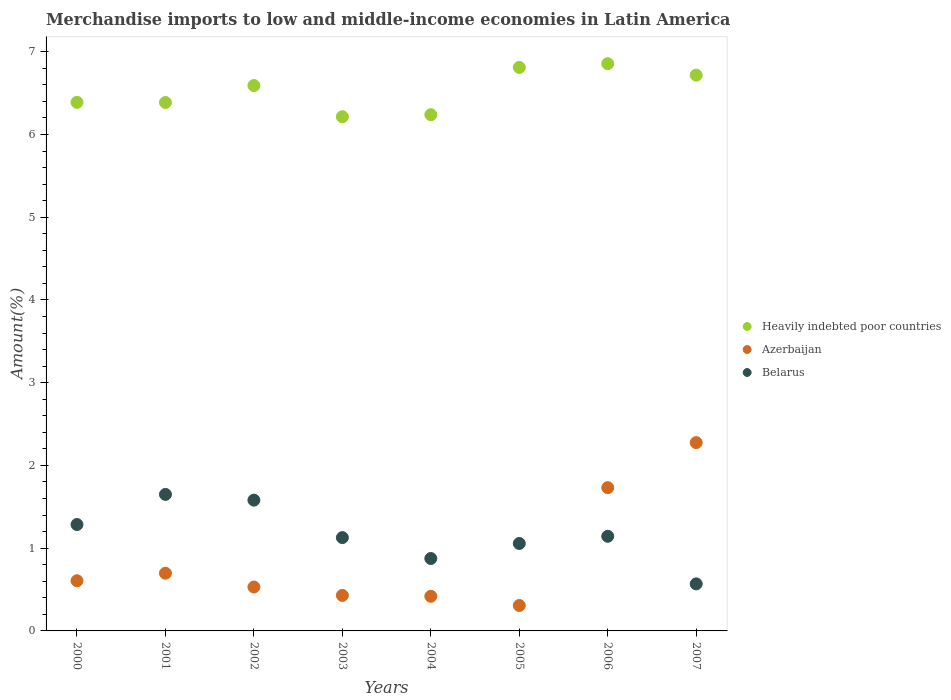Is the number of dotlines equal to the number of legend labels?
Keep it short and to the point. Yes. What is the percentage of amount earned from merchandise imports in Belarus in 2006?
Give a very brief answer. 1.14. Across all years, what is the maximum percentage of amount earned from merchandise imports in Belarus?
Keep it short and to the point. 1.65. Across all years, what is the minimum percentage of amount earned from merchandise imports in Belarus?
Offer a very short reply. 0.57. What is the total percentage of amount earned from merchandise imports in Azerbaijan in the graph?
Your response must be concise. 7. What is the difference between the percentage of amount earned from merchandise imports in Heavily indebted poor countries in 2000 and that in 2005?
Keep it short and to the point. -0.42. What is the difference between the percentage of amount earned from merchandise imports in Belarus in 2001 and the percentage of amount earned from merchandise imports in Azerbaijan in 2007?
Provide a short and direct response. -0.63. What is the average percentage of amount earned from merchandise imports in Azerbaijan per year?
Your answer should be compact. 0.87. In the year 2006, what is the difference between the percentage of amount earned from merchandise imports in Azerbaijan and percentage of amount earned from merchandise imports in Heavily indebted poor countries?
Make the answer very short. -5.12. What is the ratio of the percentage of amount earned from merchandise imports in Belarus in 2003 to that in 2006?
Give a very brief answer. 0.99. Is the difference between the percentage of amount earned from merchandise imports in Azerbaijan in 2001 and 2005 greater than the difference between the percentage of amount earned from merchandise imports in Heavily indebted poor countries in 2001 and 2005?
Offer a very short reply. Yes. What is the difference between the highest and the second highest percentage of amount earned from merchandise imports in Heavily indebted poor countries?
Provide a short and direct response. 0.05. What is the difference between the highest and the lowest percentage of amount earned from merchandise imports in Belarus?
Give a very brief answer. 1.08. Is the sum of the percentage of amount earned from merchandise imports in Azerbaijan in 2001 and 2002 greater than the maximum percentage of amount earned from merchandise imports in Heavily indebted poor countries across all years?
Provide a short and direct response. No. Is it the case that in every year, the sum of the percentage of amount earned from merchandise imports in Azerbaijan and percentage of amount earned from merchandise imports in Heavily indebted poor countries  is greater than the percentage of amount earned from merchandise imports in Belarus?
Keep it short and to the point. Yes. Is the percentage of amount earned from merchandise imports in Belarus strictly less than the percentage of amount earned from merchandise imports in Azerbaijan over the years?
Make the answer very short. No. How many dotlines are there?
Offer a terse response. 3. What is the difference between two consecutive major ticks on the Y-axis?
Offer a very short reply. 1. Does the graph contain grids?
Your answer should be very brief. No. How are the legend labels stacked?
Ensure brevity in your answer.  Vertical. What is the title of the graph?
Provide a short and direct response. Merchandise imports to low and middle-income economies in Latin America. Does "Azerbaijan" appear as one of the legend labels in the graph?
Make the answer very short. Yes. What is the label or title of the Y-axis?
Your response must be concise. Amount(%). What is the Amount(%) of Heavily indebted poor countries in 2000?
Keep it short and to the point. 6.39. What is the Amount(%) of Azerbaijan in 2000?
Ensure brevity in your answer.  0.61. What is the Amount(%) of Belarus in 2000?
Your response must be concise. 1.29. What is the Amount(%) in Heavily indebted poor countries in 2001?
Offer a very short reply. 6.39. What is the Amount(%) in Azerbaijan in 2001?
Provide a short and direct response. 0.7. What is the Amount(%) in Belarus in 2001?
Give a very brief answer. 1.65. What is the Amount(%) of Heavily indebted poor countries in 2002?
Give a very brief answer. 6.59. What is the Amount(%) of Azerbaijan in 2002?
Provide a succinct answer. 0.53. What is the Amount(%) in Belarus in 2002?
Offer a very short reply. 1.58. What is the Amount(%) in Heavily indebted poor countries in 2003?
Your answer should be compact. 6.21. What is the Amount(%) in Azerbaijan in 2003?
Give a very brief answer. 0.43. What is the Amount(%) in Belarus in 2003?
Your response must be concise. 1.13. What is the Amount(%) of Heavily indebted poor countries in 2004?
Make the answer very short. 6.24. What is the Amount(%) in Azerbaijan in 2004?
Give a very brief answer. 0.42. What is the Amount(%) of Belarus in 2004?
Your answer should be very brief. 0.88. What is the Amount(%) of Heavily indebted poor countries in 2005?
Keep it short and to the point. 6.81. What is the Amount(%) of Azerbaijan in 2005?
Make the answer very short. 0.31. What is the Amount(%) of Belarus in 2005?
Offer a very short reply. 1.06. What is the Amount(%) of Heavily indebted poor countries in 2006?
Offer a very short reply. 6.86. What is the Amount(%) of Azerbaijan in 2006?
Offer a terse response. 1.73. What is the Amount(%) of Belarus in 2006?
Make the answer very short. 1.14. What is the Amount(%) of Heavily indebted poor countries in 2007?
Offer a very short reply. 6.72. What is the Amount(%) in Azerbaijan in 2007?
Keep it short and to the point. 2.28. What is the Amount(%) of Belarus in 2007?
Your answer should be compact. 0.57. Across all years, what is the maximum Amount(%) of Heavily indebted poor countries?
Provide a short and direct response. 6.86. Across all years, what is the maximum Amount(%) of Azerbaijan?
Provide a short and direct response. 2.28. Across all years, what is the maximum Amount(%) in Belarus?
Offer a very short reply. 1.65. Across all years, what is the minimum Amount(%) of Heavily indebted poor countries?
Offer a terse response. 6.21. Across all years, what is the minimum Amount(%) of Azerbaijan?
Offer a terse response. 0.31. Across all years, what is the minimum Amount(%) of Belarus?
Your answer should be very brief. 0.57. What is the total Amount(%) of Heavily indebted poor countries in the graph?
Provide a succinct answer. 52.2. What is the total Amount(%) in Azerbaijan in the graph?
Keep it short and to the point. 7. What is the total Amount(%) in Belarus in the graph?
Make the answer very short. 9.29. What is the difference between the Amount(%) in Heavily indebted poor countries in 2000 and that in 2001?
Offer a terse response. 0. What is the difference between the Amount(%) in Azerbaijan in 2000 and that in 2001?
Ensure brevity in your answer.  -0.09. What is the difference between the Amount(%) in Belarus in 2000 and that in 2001?
Offer a terse response. -0.36. What is the difference between the Amount(%) in Heavily indebted poor countries in 2000 and that in 2002?
Offer a terse response. -0.2. What is the difference between the Amount(%) in Azerbaijan in 2000 and that in 2002?
Offer a very short reply. 0.08. What is the difference between the Amount(%) of Belarus in 2000 and that in 2002?
Give a very brief answer. -0.29. What is the difference between the Amount(%) in Heavily indebted poor countries in 2000 and that in 2003?
Your answer should be very brief. 0.17. What is the difference between the Amount(%) in Azerbaijan in 2000 and that in 2003?
Keep it short and to the point. 0.18. What is the difference between the Amount(%) of Belarus in 2000 and that in 2003?
Your answer should be compact. 0.16. What is the difference between the Amount(%) in Heavily indebted poor countries in 2000 and that in 2004?
Provide a succinct answer. 0.15. What is the difference between the Amount(%) of Azerbaijan in 2000 and that in 2004?
Provide a short and direct response. 0.19. What is the difference between the Amount(%) of Belarus in 2000 and that in 2004?
Offer a terse response. 0.41. What is the difference between the Amount(%) of Heavily indebted poor countries in 2000 and that in 2005?
Your answer should be very brief. -0.42. What is the difference between the Amount(%) of Azerbaijan in 2000 and that in 2005?
Your answer should be compact. 0.3. What is the difference between the Amount(%) in Belarus in 2000 and that in 2005?
Offer a terse response. 0.23. What is the difference between the Amount(%) of Heavily indebted poor countries in 2000 and that in 2006?
Ensure brevity in your answer.  -0.47. What is the difference between the Amount(%) in Azerbaijan in 2000 and that in 2006?
Your answer should be compact. -1.12. What is the difference between the Amount(%) of Belarus in 2000 and that in 2006?
Your response must be concise. 0.14. What is the difference between the Amount(%) in Heavily indebted poor countries in 2000 and that in 2007?
Provide a succinct answer. -0.33. What is the difference between the Amount(%) of Azerbaijan in 2000 and that in 2007?
Offer a very short reply. -1.67. What is the difference between the Amount(%) in Belarus in 2000 and that in 2007?
Provide a succinct answer. 0.72. What is the difference between the Amount(%) of Heavily indebted poor countries in 2001 and that in 2002?
Your answer should be very brief. -0.2. What is the difference between the Amount(%) in Azerbaijan in 2001 and that in 2002?
Provide a succinct answer. 0.17. What is the difference between the Amount(%) of Belarus in 2001 and that in 2002?
Your response must be concise. 0.07. What is the difference between the Amount(%) of Heavily indebted poor countries in 2001 and that in 2003?
Provide a short and direct response. 0.17. What is the difference between the Amount(%) of Azerbaijan in 2001 and that in 2003?
Provide a succinct answer. 0.27. What is the difference between the Amount(%) of Belarus in 2001 and that in 2003?
Offer a terse response. 0.52. What is the difference between the Amount(%) of Heavily indebted poor countries in 2001 and that in 2004?
Provide a succinct answer. 0.15. What is the difference between the Amount(%) in Azerbaijan in 2001 and that in 2004?
Ensure brevity in your answer.  0.28. What is the difference between the Amount(%) in Belarus in 2001 and that in 2004?
Your response must be concise. 0.77. What is the difference between the Amount(%) of Heavily indebted poor countries in 2001 and that in 2005?
Offer a very short reply. -0.42. What is the difference between the Amount(%) in Azerbaijan in 2001 and that in 2005?
Ensure brevity in your answer.  0.39. What is the difference between the Amount(%) in Belarus in 2001 and that in 2005?
Give a very brief answer. 0.59. What is the difference between the Amount(%) of Heavily indebted poor countries in 2001 and that in 2006?
Your answer should be very brief. -0.47. What is the difference between the Amount(%) of Azerbaijan in 2001 and that in 2006?
Provide a succinct answer. -1.03. What is the difference between the Amount(%) in Belarus in 2001 and that in 2006?
Your answer should be compact. 0.51. What is the difference between the Amount(%) of Heavily indebted poor countries in 2001 and that in 2007?
Provide a short and direct response. -0.33. What is the difference between the Amount(%) in Azerbaijan in 2001 and that in 2007?
Offer a very short reply. -1.58. What is the difference between the Amount(%) of Belarus in 2001 and that in 2007?
Offer a terse response. 1.08. What is the difference between the Amount(%) in Heavily indebted poor countries in 2002 and that in 2003?
Your response must be concise. 0.38. What is the difference between the Amount(%) in Azerbaijan in 2002 and that in 2003?
Offer a very short reply. 0.1. What is the difference between the Amount(%) in Belarus in 2002 and that in 2003?
Your answer should be very brief. 0.45. What is the difference between the Amount(%) of Heavily indebted poor countries in 2002 and that in 2004?
Your answer should be compact. 0.35. What is the difference between the Amount(%) of Azerbaijan in 2002 and that in 2004?
Make the answer very short. 0.11. What is the difference between the Amount(%) of Belarus in 2002 and that in 2004?
Keep it short and to the point. 0.71. What is the difference between the Amount(%) of Heavily indebted poor countries in 2002 and that in 2005?
Keep it short and to the point. -0.22. What is the difference between the Amount(%) of Azerbaijan in 2002 and that in 2005?
Make the answer very short. 0.22. What is the difference between the Amount(%) of Belarus in 2002 and that in 2005?
Your response must be concise. 0.52. What is the difference between the Amount(%) of Heavily indebted poor countries in 2002 and that in 2006?
Provide a succinct answer. -0.26. What is the difference between the Amount(%) in Azerbaijan in 2002 and that in 2006?
Your answer should be compact. -1.2. What is the difference between the Amount(%) of Belarus in 2002 and that in 2006?
Your answer should be compact. 0.44. What is the difference between the Amount(%) of Heavily indebted poor countries in 2002 and that in 2007?
Give a very brief answer. -0.13. What is the difference between the Amount(%) of Azerbaijan in 2002 and that in 2007?
Provide a short and direct response. -1.75. What is the difference between the Amount(%) in Heavily indebted poor countries in 2003 and that in 2004?
Make the answer very short. -0.02. What is the difference between the Amount(%) of Azerbaijan in 2003 and that in 2004?
Provide a short and direct response. 0.01. What is the difference between the Amount(%) in Belarus in 2003 and that in 2004?
Your response must be concise. 0.25. What is the difference between the Amount(%) of Heavily indebted poor countries in 2003 and that in 2005?
Ensure brevity in your answer.  -0.6. What is the difference between the Amount(%) in Azerbaijan in 2003 and that in 2005?
Your answer should be very brief. 0.12. What is the difference between the Amount(%) of Belarus in 2003 and that in 2005?
Offer a very short reply. 0.07. What is the difference between the Amount(%) of Heavily indebted poor countries in 2003 and that in 2006?
Your response must be concise. -0.64. What is the difference between the Amount(%) in Azerbaijan in 2003 and that in 2006?
Give a very brief answer. -1.3. What is the difference between the Amount(%) in Belarus in 2003 and that in 2006?
Give a very brief answer. -0.02. What is the difference between the Amount(%) in Heavily indebted poor countries in 2003 and that in 2007?
Provide a short and direct response. -0.5. What is the difference between the Amount(%) of Azerbaijan in 2003 and that in 2007?
Provide a short and direct response. -1.85. What is the difference between the Amount(%) of Belarus in 2003 and that in 2007?
Offer a very short reply. 0.56. What is the difference between the Amount(%) of Heavily indebted poor countries in 2004 and that in 2005?
Provide a succinct answer. -0.57. What is the difference between the Amount(%) of Azerbaijan in 2004 and that in 2005?
Provide a short and direct response. 0.11. What is the difference between the Amount(%) of Belarus in 2004 and that in 2005?
Keep it short and to the point. -0.18. What is the difference between the Amount(%) in Heavily indebted poor countries in 2004 and that in 2006?
Give a very brief answer. -0.62. What is the difference between the Amount(%) in Azerbaijan in 2004 and that in 2006?
Your answer should be compact. -1.31. What is the difference between the Amount(%) of Belarus in 2004 and that in 2006?
Provide a short and direct response. -0.27. What is the difference between the Amount(%) of Heavily indebted poor countries in 2004 and that in 2007?
Give a very brief answer. -0.48. What is the difference between the Amount(%) in Azerbaijan in 2004 and that in 2007?
Your answer should be compact. -1.86. What is the difference between the Amount(%) of Belarus in 2004 and that in 2007?
Make the answer very short. 0.31. What is the difference between the Amount(%) of Heavily indebted poor countries in 2005 and that in 2006?
Provide a succinct answer. -0.05. What is the difference between the Amount(%) of Azerbaijan in 2005 and that in 2006?
Your response must be concise. -1.42. What is the difference between the Amount(%) of Belarus in 2005 and that in 2006?
Keep it short and to the point. -0.09. What is the difference between the Amount(%) of Heavily indebted poor countries in 2005 and that in 2007?
Make the answer very short. 0.09. What is the difference between the Amount(%) in Azerbaijan in 2005 and that in 2007?
Provide a succinct answer. -1.97. What is the difference between the Amount(%) in Belarus in 2005 and that in 2007?
Your response must be concise. 0.49. What is the difference between the Amount(%) of Heavily indebted poor countries in 2006 and that in 2007?
Your response must be concise. 0.14. What is the difference between the Amount(%) in Azerbaijan in 2006 and that in 2007?
Offer a terse response. -0.54. What is the difference between the Amount(%) in Belarus in 2006 and that in 2007?
Keep it short and to the point. 0.58. What is the difference between the Amount(%) of Heavily indebted poor countries in 2000 and the Amount(%) of Azerbaijan in 2001?
Ensure brevity in your answer.  5.69. What is the difference between the Amount(%) of Heavily indebted poor countries in 2000 and the Amount(%) of Belarus in 2001?
Ensure brevity in your answer.  4.74. What is the difference between the Amount(%) of Azerbaijan in 2000 and the Amount(%) of Belarus in 2001?
Your response must be concise. -1.04. What is the difference between the Amount(%) of Heavily indebted poor countries in 2000 and the Amount(%) of Azerbaijan in 2002?
Make the answer very short. 5.86. What is the difference between the Amount(%) of Heavily indebted poor countries in 2000 and the Amount(%) of Belarus in 2002?
Ensure brevity in your answer.  4.81. What is the difference between the Amount(%) in Azerbaijan in 2000 and the Amount(%) in Belarus in 2002?
Provide a short and direct response. -0.97. What is the difference between the Amount(%) of Heavily indebted poor countries in 2000 and the Amount(%) of Azerbaijan in 2003?
Keep it short and to the point. 5.96. What is the difference between the Amount(%) in Heavily indebted poor countries in 2000 and the Amount(%) in Belarus in 2003?
Make the answer very short. 5.26. What is the difference between the Amount(%) of Azerbaijan in 2000 and the Amount(%) of Belarus in 2003?
Offer a very short reply. -0.52. What is the difference between the Amount(%) of Heavily indebted poor countries in 2000 and the Amount(%) of Azerbaijan in 2004?
Offer a very short reply. 5.97. What is the difference between the Amount(%) of Heavily indebted poor countries in 2000 and the Amount(%) of Belarus in 2004?
Your answer should be very brief. 5.51. What is the difference between the Amount(%) in Azerbaijan in 2000 and the Amount(%) in Belarus in 2004?
Give a very brief answer. -0.27. What is the difference between the Amount(%) of Heavily indebted poor countries in 2000 and the Amount(%) of Azerbaijan in 2005?
Your response must be concise. 6.08. What is the difference between the Amount(%) in Heavily indebted poor countries in 2000 and the Amount(%) in Belarus in 2005?
Keep it short and to the point. 5.33. What is the difference between the Amount(%) in Azerbaijan in 2000 and the Amount(%) in Belarus in 2005?
Offer a terse response. -0.45. What is the difference between the Amount(%) of Heavily indebted poor countries in 2000 and the Amount(%) of Azerbaijan in 2006?
Your answer should be very brief. 4.66. What is the difference between the Amount(%) in Heavily indebted poor countries in 2000 and the Amount(%) in Belarus in 2006?
Offer a terse response. 5.24. What is the difference between the Amount(%) in Azerbaijan in 2000 and the Amount(%) in Belarus in 2006?
Your answer should be very brief. -0.54. What is the difference between the Amount(%) of Heavily indebted poor countries in 2000 and the Amount(%) of Azerbaijan in 2007?
Give a very brief answer. 4.11. What is the difference between the Amount(%) of Heavily indebted poor countries in 2000 and the Amount(%) of Belarus in 2007?
Provide a short and direct response. 5.82. What is the difference between the Amount(%) of Azerbaijan in 2000 and the Amount(%) of Belarus in 2007?
Make the answer very short. 0.04. What is the difference between the Amount(%) of Heavily indebted poor countries in 2001 and the Amount(%) of Azerbaijan in 2002?
Provide a succinct answer. 5.86. What is the difference between the Amount(%) of Heavily indebted poor countries in 2001 and the Amount(%) of Belarus in 2002?
Give a very brief answer. 4.81. What is the difference between the Amount(%) of Azerbaijan in 2001 and the Amount(%) of Belarus in 2002?
Provide a short and direct response. -0.88. What is the difference between the Amount(%) of Heavily indebted poor countries in 2001 and the Amount(%) of Azerbaijan in 2003?
Ensure brevity in your answer.  5.96. What is the difference between the Amount(%) of Heavily indebted poor countries in 2001 and the Amount(%) of Belarus in 2003?
Your response must be concise. 5.26. What is the difference between the Amount(%) of Azerbaijan in 2001 and the Amount(%) of Belarus in 2003?
Your answer should be compact. -0.43. What is the difference between the Amount(%) in Heavily indebted poor countries in 2001 and the Amount(%) in Azerbaijan in 2004?
Your response must be concise. 5.97. What is the difference between the Amount(%) of Heavily indebted poor countries in 2001 and the Amount(%) of Belarus in 2004?
Make the answer very short. 5.51. What is the difference between the Amount(%) in Azerbaijan in 2001 and the Amount(%) in Belarus in 2004?
Keep it short and to the point. -0.18. What is the difference between the Amount(%) of Heavily indebted poor countries in 2001 and the Amount(%) of Azerbaijan in 2005?
Keep it short and to the point. 6.08. What is the difference between the Amount(%) of Heavily indebted poor countries in 2001 and the Amount(%) of Belarus in 2005?
Your response must be concise. 5.33. What is the difference between the Amount(%) in Azerbaijan in 2001 and the Amount(%) in Belarus in 2005?
Your response must be concise. -0.36. What is the difference between the Amount(%) in Heavily indebted poor countries in 2001 and the Amount(%) in Azerbaijan in 2006?
Offer a very short reply. 4.66. What is the difference between the Amount(%) of Heavily indebted poor countries in 2001 and the Amount(%) of Belarus in 2006?
Offer a very short reply. 5.24. What is the difference between the Amount(%) in Azerbaijan in 2001 and the Amount(%) in Belarus in 2006?
Keep it short and to the point. -0.45. What is the difference between the Amount(%) in Heavily indebted poor countries in 2001 and the Amount(%) in Azerbaijan in 2007?
Offer a very short reply. 4.11. What is the difference between the Amount(%) of Heavily indebted poor countries in 2001 and the Amount(%) of Belarus in 2007?
Provide a succinct answer. 5.82. What is the difference between the Amount(%) in Azerbaijan in 2001 and the Amount(%) in Belarus in 2007?
Ensure brevity in your answer.  0.13. What is the difference between the Amount(%) in Heavily indebted poor countries in 2002 and the Amount(%) in Azerbaijan in 2003?
Provide a short and direct response. 6.16. What is the difference between the Amount(%) in Heavily indebted poor countries in 2002 and the Amount(%) in Belarus in 2003?
Your answer should be very brief. 5.46. What is the difference between the Amount(%) of Azerbaijan in 2002 and the Amount(%) of Belarus in 2003?
Offer a terse response. -0.6. What is the difference between the Amount(%) in Heavily indebted poor countries in 2002 and the Amount(%) in Azerbaijan in 2004?
Your answer should be compact. 6.17. What is the difference between the Amount(%) in Heavily indebted poor countries in 2002 and the Amount(%) in Belarus in 2004?
Provide a short and direct response. 5.72. What is the difference between the Amount(%) in Azerbaijan in 2002 and the Amount(%) in Belarus in 2004?
Keep it short and to the point. -0.34. What is the difference between the Amount(%) of Heavily indebted poor countries in 2002 and the Amount(%) of Azerbaijan in 2005?
Your response must be concise. 6.28. What is the difference between the Amount(%) of Heavily indebted poor countries in 2002 and the Amount(%) of Belarus in 2005?
Keep it short and to the point. 5.53. What is the difference between the Amount(%) in Azerbaijan in 2002 and the Amount(%) in Belarus in 2005?
Offer a terse response. -0.53. What is the difference between the Amount(%) of Heavily indebted poor countries in 2002 and the Amount(%) of Azerbaijan in 2006?
Keep it short and to the point. 4.86. What is the difference between the Amount(%) of Heavily indebted poor countries in 2002 and the Amount(%) of Belarus in 2006?
Ensure brevity in your answer.  5.45. What is the difference between the Amount(%) of Azerbaijan in 2002 and the Amount(%) of Belarus in 2006?
Offer a very short reply. -0.61. What is the difference between the Amount(%) of Heavily indebted poor countries in 2002 and the Amount(%) of Azerbaijan in 2007?
Your answer should be very brief. 4.32. What is the difference between the Amount(%) in Heavily indebted poor countries in 2002 and the Amount(%) in Belarus in 2007?
Provide a succinct answer. 6.02. What is the difference between the Amount(%) in Azerbaijan in 2002 and the Amount(%) in Belarus in 2007?
Your answer should be very brief. -0.04. What is the difference between the Amount(%) in Heavily indebted poor countries in 2003 and the Amount(%) in Azerbaijan in 2004?
Give a very brief answer. 5.8. What is the difference between the Amount(%) in Heavily indebted poor countries in 2003 and the Amount(%) in Belarus in 2004?
Give a very brief answer. 5.34. What is the difference between the Amount(%) of Azerbaijan in 2003 and the Amount(%) of Belarus in 2004?
Ensure brevity in your answer.  -0.45. What is the difference between the Amount(%) in Heavily indebted poor countries in 2003 and the Amount(%) in Azerbaijan in 2005?
Provide a short and direct response. 5.91. What is the difference between the Amount(%) in Heavily indebted poor countries in 2003 and the Amount(%) in Belarus in 2005?
Ensure brevity in your answer.  5.16. What is the difference between the Amount(%) of Azerbaijan in 2003 and the Amount(%) of Belarus in 2005?
Ensure brevity in your answer.  -0.63. What is the difference between the Amount(%) in Heavily indebted poor countries in 2003 and the Amount(%) in Azerbaijan in 2006?
Your answer should be very brief. 4.48. What is the difference between the Amount(%) of Heavily indebted poor countries in 2003 and the Amount(%) of Belarus in 2006?
Make the answer very short. 5.07. What is the difference between the Amount(%) in Azerbaijan in 2003 and the Amount(%) in Belarus in 2006?
Give a very brief answer. -0.71. What is the difference between the Amount(%) of Heavily indebted poor countries in 2003 and the Amount(%) of Azerbaijan in 2007?
Give a very brief answer. 3.94. What is the difference between the Amount(%) of Heavily indebted poor countries in 2003 and the Amount(%) of Belarus in 2007?
Provide a short and direct response. 5.65. What is the difference between the Amount(%) in Azerbaijan in 2003 and the Amount(%) in Belarus in 2007?
Make the answer very short. -0.14. What is the difference between the Amount(%) of Heavily indebted poor countries in 2004 and the Amount(%) of Azerbaijan in 2005?
Offer a terse response. 5.93. What is the difference between the Amount(%) of Heavily indebted poor countries in 2004 and the Amount(%) of Belarus in 2005?
Your answer should be very brief. 5.18. What is the difference between the Amount(%) of Azerbaijan in 2004 and the Amount(%) of Belarus in 2005?
Offer a very short reply. -0.64. What is the difference between the Amount(%) of Heavily indebted poor countries in 2004 and the Amount(%) of Azerbaijan in 2006?
Make the answer very short. 4.51. What is the difference between the Amount(%) of Heavily indebted poor countries in 2004 and the Amount(%) of Belarus in 2006?
Provide a short and direct response. 5.1. What is the difference between the Amount(%) of Azerbaijan in 2004 and the Amount(%) of Belarus in 2006?
Make the answer very short. -0.73. What is the difference between the Amount(%) of Heavily indebted poor countries in 2004 and the Amount(%) of Azerbaijan in 2007?
Make the answer very short. 3.96. What is the difference between the Amount(%) in Heavily indebted poor countries in 2004 and the Amount(%) in Belarus in 2007?
Offer a very short reply. 5.67. What is the difference between the Amount(%) in Azerbaijan in 2004 and the Amount(%) in Belarus in 2007?
Give a very brief answer. -0.15. What is the difference between the Amount(%) of Heavily indebted poor countries in 2005 and the Amount(%) of Azerbaijan in 2006?
Provide a short and direct response. 5.08. What is the difference between the Amount(%) of Heavily indebted poor countries in 2005 and the Amount(%) of Belarus in 2006?
Ensure brevity in your answer.  5.67. What is the difference between the Amount(%) in Azerbaijan in 2005 and the Amount(%) in Belarus in 2006?
Your answer should be very brief. -0.84. What is the difference between the Amount(%) of Heavily indebted poor countries in 2005 and the Amount(%) of Azerbaijan in 2007?
Your answer should be very brief. 4.53. What is the difference between the Amount(%) in Heavily indebted poor countries in 2005 and the Amount(%) in Belarus in 2007?
Offer a terse response. 6.24. What is the difference between the Amount(%) in Azerbaijan in 2005 and the Amount(%) in Belarus in 2007?
Offer a terse response. -0.26. What is the difference between the Amount(%) of Heavily indebted poor countries in 2006 and the Amount(%) of Azerbaijan in 2007?
Your answer should be very brief. 4.58. What is the difference between the Amount(%) of Heavily indebted poor countries in 2006 and the Amount(%) of Belarus in 2007?
Your response must be concise. 6.29. What is the difference between the Amount(%) in Azerbaijan in 2006 and the Amount(%) in Belarus in 2007?
Offer a terse response. 1.16. What is the average Amount(%) in Heavily indebted poor countries per year?
Offer a terse response. 6.53. What is the average Amount(%) in Azerbaijan per year?
Make the answer very short. 0.87. What is the average Amount(%) in Belarus per year?
Make the answer very short. 1.16. In the year 2000, what is the difference between the Amount(%) in Heavily indebted poor countries and Amount(%) in Azerbaijan?
Provide a short and direct response. 5.78. In the year 2000, what is the difference between the Amount(%) in Heavily indebted poor countries and Amount(%) in Belarus?
Your answer should be very brief. 5.1. In the year 2000, what is the difference between the Amount(%) of Azerbaijan and Amount(%) of Belarus?
Ensure brevity in your answer.  -0.68. In the year 2001, what is the difference between the Amount(%) in Heavily indebted poor countries and Amount(%) in Azerbaijan?
Offer a very short reply. 5.69. In the year 2001, what is the difference between the Amount(%) in Heavily indebted poor countries and Amount(%) in Belarus?
Provide a short and direct response. 4.74. In the year 2001, what is the difference between the Amount(%) of Azerbaijan and Amount(%) of Belarus?
Provide a succinct answer. -0.95. In the year 2002, what is the difference between the Amount(%) of Heavily indebted poor countries and Amount(%) of Azerbaijan?
Your answer should be very brief. 6.06. In the year 2002, what is the difference between the Amount(%) of Heavily indebted poor countries and Amount(%) of Belarus?
Offer a terse response. 5.01. In the year 2002, what is the difference between the Amount(%) of Azerbaijan and Amount(%) of Belarus?
Your answer should be very brief. -1.05. In the year 2003, what is the difference between the Amount(%) in Heavily indebted poor countries and Amount(%) in Azerbaijan?
Your answer should be very brief. 5.79. In the year 2003, what is the difference between the Amount(%) in Heavily indebted poor countries and Amount(%) in Belarus?
Give a very brief answer. 5.09. In the year 2003, what is the difference between the Amount(%) in Azerbaijan and Amount(%) in Belarus?
Provide a succinct answer. -0.7. In the year 2004, what is the difference between the Amount(%) in Heavily indebted poor countries and Amount(%) in Azerbaijan?
Your answer should be very brief. 5.82. In the year 2004, what is the difference between the Amount(%) of Heavily indebted poor countries and Amount(%) of Belarus?
Offer a terse response. 5.36. In the year 2004, what is the difference between the Amount(%) of Azerbaijan and Amount(%) of Belarus?
Offer a terse response. -0.46. In the year 2005, what is the difference between the Amount(%) in Heavily indebted poor countries and Amount(%) in Azerbaijan?
Your answer should be compact. 6.5. In the year 2005, what is the difference between the Amount(%) of Heavily indebted poor countries and Amount(%) of Belarus?
Your response must be concise. 5.75. In the year 2005, what is the difference between the Amount(%) in Azerbaijan and Amount(%) in Belarus?
Offer a very short reply. -0.75. In the year 2006, what is the difference between the Amount(%) of Heavily indebted poor countries and Amount(%) of Azerbaijan?
Keep it short and to the point. 5.12. In the year 2006, what is the difference between the Amount(%) in Heavily indebted poor countries and Amount(%) in Belarus?
Give a very brief answer. 5.71. In the year 2006, what is the difference between the Amount(%) in Azerbaijan and Amount(%) in Belarus?
Offer a very short reply. 0.59. In the year 2007, what is the difference between the Amount(%) in Heavily indebted poor countries and Amount(%) in Azerbaijan?
Keep it short and to the point. 4.44. In the year 2007, what is the difference between the Amount(%) in Heavily indebted poor countries and Amount(%) in Belarus?
Offer a terse response. 6.15. In the year 2007, what is the difference between the Amount(%) of Azerbaijan and Amount(%) of Belarus?
Provide a short and direct response. 1.71. What is the ratio of the Amount(%) of Heavily indebted poor countries in 2000 to that in 2001?
Ensure brevity in your answer.  1. What is the ratio of the Amount(%) in Azerbaijan in 2000 to that in 2001?
Provide a short and direct response. 0.87. What is the ratio of the Amount(%) in Belarus in 2000 to that in 2001?
Provide a short and direct response. 0.78. What is the ratio of the Amount(%) of Heavily indebted poor countries in 2000 to that in 2002?
Give a very brief answer. 0.97. What is the ratio of the Amount(%) of Azerbaijan in 2000 to that in 2002?
Offer a very short reply. 1.14. What is the ratio of the Amount(%) of Belarus in 2000 to that in 2002?
Your response must be concise. 0.81. What is the ratio of the Amount(%) in Heavily indebted poor countries in 2000 to that in 2003?
Your response must be concise. 1.03. What is the ratio of the Amount(%) of Azerbaijan in 2000 to that in 2003?
Provide a succinct answer. 1.41. What is the ratio of the Amount(%) of Belarus in 2000 to that in 2003?
Make the answer very short. 1.14. What is the ratio of the Amount(%) in Heavily indebted poor countries in 2000 to that in 2004?
Your response must be concise. 1.02. What is the ratio of the Amount(%) in Azerbaijan in 2000 to that in 2004?
Offer a terse response. 1.45. What is the ratio of the Amount(%) in Belarus in 2000 to that in 2004?
Ensure brevity in your answer.  1.47. What is the ratio of the Amount(%) in Heavily indebted poor countries in 2000 to that in 2005?
Make the answer very short. 0.94. What is the ratio of the Amount(%) in Azerbaijan in 2000 to that in 2005?
Ensure brevity in your answer.  1.97. What is the ratio of the Amount(%) in Belarus in 2000 to that in 2005?
Your response must be concise. 1.22. What is the ratio of the Amount(%) of Heavily indebted poor countries in 2000 to that in 2006?
Make the answer very short. 0.93. What is the ratio of the Amount(%) in Azerbaijan in 2000 to that in 2006?
Give a very brief answer. 0.35. What is the ratio of the Amount(%) in Belarus in 2000 to that in 2006?
Provide a succinct answer. 1.12. What is the ratio of the Amount(%) in Heavily indebted poor countries in 2000 to that in 2007?
Offer a very short reply. 0.95. What is the ratio of the Amount(%) of Azerbaijan in 2000 to that in 2007?
Offer a terse response. 0.27. What is the ratio of the Amount(%) of Belarus in 2000 to that in 2007?
Keep it short and to the point. 2.26. What is the ratio of the Amount(%) in Heavily indebted poor countries in 2001 to that in 2002?
Provide a short and direct response. 0.97. What is the ratio of the Amount(%) in Azerbaijan in 2001 to that in 2002?
Provide a succinct answer. 1.31. What is the ratio of the Amount(%) in Belarus in 2001 to that in 2002?
Make the answer very short. 1.04. What is the ratio of the Amount(%) in Heavily indebted poor countries in 2001 to that in 2003?
Provide a succinct answer. 1.03. What is the ratio of the Amount(%) of Azerbaijan in 2001 to that in 2003?
Keep it short and to the point. 1.62. What is the ratio of the Amount(%) of Belarus in 2001 to that in 2003?
Offer a terse response. 1.46. What is the ratio of the Amount(%) of Heavily indebted poor countries in 2001 to that in 2004?
Make the answer very short. 1.02. What is the ratio of the Amount(%) in Azerbaijan in 2001 to that in 2004?
Offer a terse response. 1.67. What is the ratio of the Amount(%) of Belarus in 2001 to that in 2004?
Your response must be concise. 1.89. What is the ratio of the Amount(%) of Heavily indebted poor countries in 2001 to that in 2005?
Offer a terse response. 0.94. What is the ratio of the Amount(%) of Azerbaijan in 2001 to that in 2005?
Give a very brief answer. 2.27. What is the ratio of the Amount(%) of Belarus in 2001 to that in 2005?
Provide a succinct answer. 1.56. What is the ratio of the Amount(%) of Heavily indebted poor countries in 2001 to that in 2006?
Your response must be concise. 0.93. What is the ratio of the Amount(%) of Azerbaijan in 2001 to that in 2006?
Ensure brevity in your answer.  0.4. What is the ratio of the Amount(%) in Belarus in 2001 to that in 2006?
Your answer should be compact. 1.44. What is the ratio of the Amount(%) of Heavily indebted poor countries in 2001 to that in 2007?
Your answer should be very brief. 0.95. What is the ratio of the Amount(%) in Azerbaijan in 2001 to that in 2007?
Offer a terse response. 0.31. What is the ratio of the Amount(%) in Belarus in 2001 to that in 2007?
Provide a succinct answer. 2.9. What is the ratio of the Amount(%) of Heavily indebted poor countries in 2002 to that in 2003?
Keep it short and to the point. 1.06. What is the ratio of the Amount(%) in Azerbaijan in 2002 to that in 2003?
Provide a short and direct response. 1.24. What is the ratio of the Amount(%) of Belarus in 2002 to that in 2003?
Your response must be concise. 1.4. What is the ratio of the Amount(%) of Heavily indebted poor countries in 2002 to that in 2004?
Ensure brevity in your answer.  1.06. What is the ratio of the Amount(%) of Azerbaijan in 2002 to that in 2004?
Provide a short and direct response. 1.27. What is the ratio of the Amount(%) of Belarus in 2002 to that in 2004?
Your response must be concise. 1.81. What is the ratio of the Amount(%) of Heavily indebted poor countries in 2002 to that in 2005?
Keep it short and to the point. 0.97. What is the ratio of the Amount(%) of Azerbaijan in 2002 to that in 2005?
Provide a succinct answer. 1.73. What is the ratio of the Amount(%) in Belarus in 2002 to that in 2005?
Give a very brief answer. 1.5. What is the ratio of the Amount(%) of Heavily indebted poor countries in 2002 to that in 2006?
Your answer should be compact. 0.96. What is the ratio of the Amount(%) of Azerbaijan in 2002 to that in 2006?
Keep it short and to the point. 0.31. What is the ratio of the Amount(%) in Belarus in 2002 to that in 2006?
Provide a succinct answer. 1.38. What is the ratio of the Amount(%) of Heavily indebted poor countries in 2002 to that in 2007?
Offer a terse response. 0.98. What is the ratio of the Amount(%) of Azerbaijan in 2002 to that in 2007?
Your response must be concise. 0.23. What is the ratio of the Amount(%) in Belarus in 2002 to that in 2007?
Offer a very short reply. 2.78. What is the ratio of the Amount(%) in Heavily indebted poor countries in 2003 to that in 2004?
Your response must be concise. 1. What is the ratio of the Amount(%) of Azerbaijan in 2003 to that in 2004?
Make the answer very short. 1.03. What is the ratio of the Amount(%) of Belarus in 2003 to that in 2004?
Your answer should be very brief. 1.29. What is the ratio of the Amount(%) in Heavily indebted poor countries in 2003 to that in 2005?
Provide a short and direct response. 0.91. What is the ratio of the Amount(%) in Azerbaijan in 2003 to that in 2005?
Keep it short and to the point. 1.4. What is the ratio of the Amount(%) of Belarus in 2003 to that in 2005?
Ensure brevity in your answer.  1.07. What is the ratio of the Amount(%) of Heavily indebted poor countries in 2003 to that in 2006?
Your answer should be very brief. 0.91. What is the ratio of the Amount(%) in Azerbaijan in 2003 to that in 2006?
Your response must be concise. 0.25. What is the ratio of the Amount(%) of Belarus in 2003 to that in 2006?
Your answer should be very brief. 0.99. What is the ratio of the Amount(%) in Heavily indebted poor countries in 2003 to that in 2007?
Offer a very short reply. 0.93. What is the ratio of the Amount(%) of Azerbaijan in 2003 to that in 2007?
Your answer should be very brief. 0.19. What is the ratio of the Amount(%) of Belarus in 2003 to that in 2007?
Your answer should be compact. 1.98. What is the ratio of the Amount(%) in Heavily indebted poor countries in 2004 to that in 2005?
Ensure brevity in your answer.  0.92. What is the ratio of the Amount(%) of Azerbaijan in 2004 to that in 2005?
Your answer should be very brief. 1.36. What is the ratio of the Amount(%) of Belarus in 2004 to that in 2005?
Provide a succinct answer. 0.83. What is the ratio of the Amount(%) in Heavily indebted poor countries in 2004 to that in 2006?
Offer a very short reply. 0.91. What is the ratio of the Amount(%) of Azerbaijan in 2004 to that in 2006?
Provide a succinct answer. 0.24. What is the ratio of the Amount(%) of Belarus in 2004 to that in 2006?
Ensure brevity in your answer.  0.77. What is the ratio of the Amount(%) in Heavily indebted poor countries in 2004 to that in 2007?
Provide a short and direct response. 0.93. What is the ratio of the Amount(%) in Azerbaijan in 2004 to that in 2007?
Provide a succinct answer. 0.18. What is the ratio of the Amount(%) of Belarus in 2004 to that in 2007?
Offer a very short reply. 1.54. What is the ratio of the Amount(%) in Azerbaijan in 2005 to that in 2006?
Provide a succinct answer. 0.18. What is the ratio of the Amount(%) of Belarus in 2005 to that in 2006?
Ensure brevity in your answer.  0.92. What is the ratio of the Amount(%) in Heavily indebted poor countries in 2005 to that in 2007?
Provide a succinct answer. 1.01. What is the ratio of the Amount(%) in Azerbaijan in 2005 to that in 2007?
Your answer should be compact. 0.13. What is the ratio of the Amount(%) of Belarus in 2005 to that in 2007?
Provide a short and direct response. 1.86. What is the ratio of the Amount(%) of Heavily indebted poor countries in 2006 to that in 2007?
Ensure brevity in your answer.  1.02. What is the ratio of the Amount(%) of Azerbaijan in 2006 to that in 2007?
Your response must be concise. 0.76. What is the ratio of the Amount(%) of Belarus in 2006 to that in 2007?
Offer a very short reply. 2.01. What is the difference between the highest and the second highest Amount(%) of Heavily indebted poor countries?
Provide a succinct answer. 0.05. What is the difference between the highest and the second highest Amount(%) of Azerbaijan?
Ensure brevity in your answer.  0.54. What is the difference between the highest and the second highest Amount(%) in Belarus?
Provide a succinct answer. 0.07. What is the difference between the highest and the lowest Amount(%) in Heavily indebted poor countries?
Provide a succinct answer. 0.64. What is the difference between the highest and the lowest Amount(%) of Azerbaijan?
Provide a short and direct response. 1.97. What is the difference between the highest and the lowest Amount(%) of Belarus?
Offer a terse response. 1.08. 